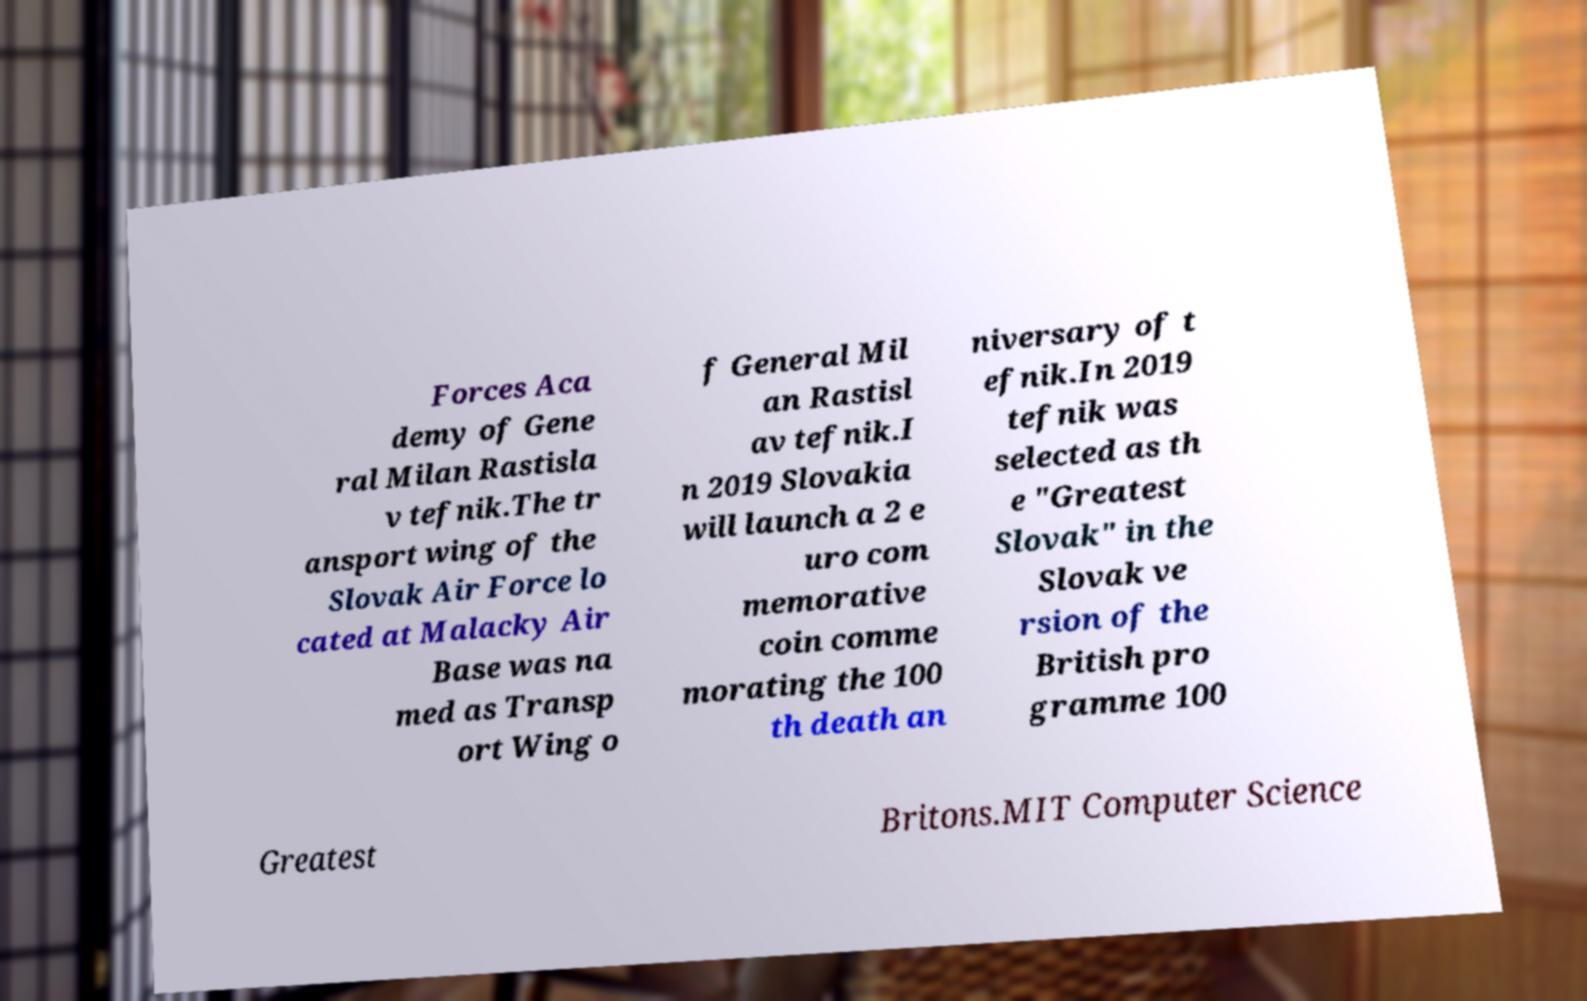Please identify and transcribe the text found in this image. Forces Aca demy of Gene ral Milan Rastisla v tefnik.The tr ansport wing of the Slovak Air Force lo cated at Malacky Air Base was na med as Transp ort Wing o f General Mil an Rastisl av tefnik.I n 2019 Slovakia will launch a 2 e uro com memorative coin comme morating the 100 th death an niversary of t efnik.In 2019 tefnik was selected as th e "Greatest Slovak" in the Slovak ve rsion of the British pro gramme 100 Greatest Britons.MIT Computer Science 